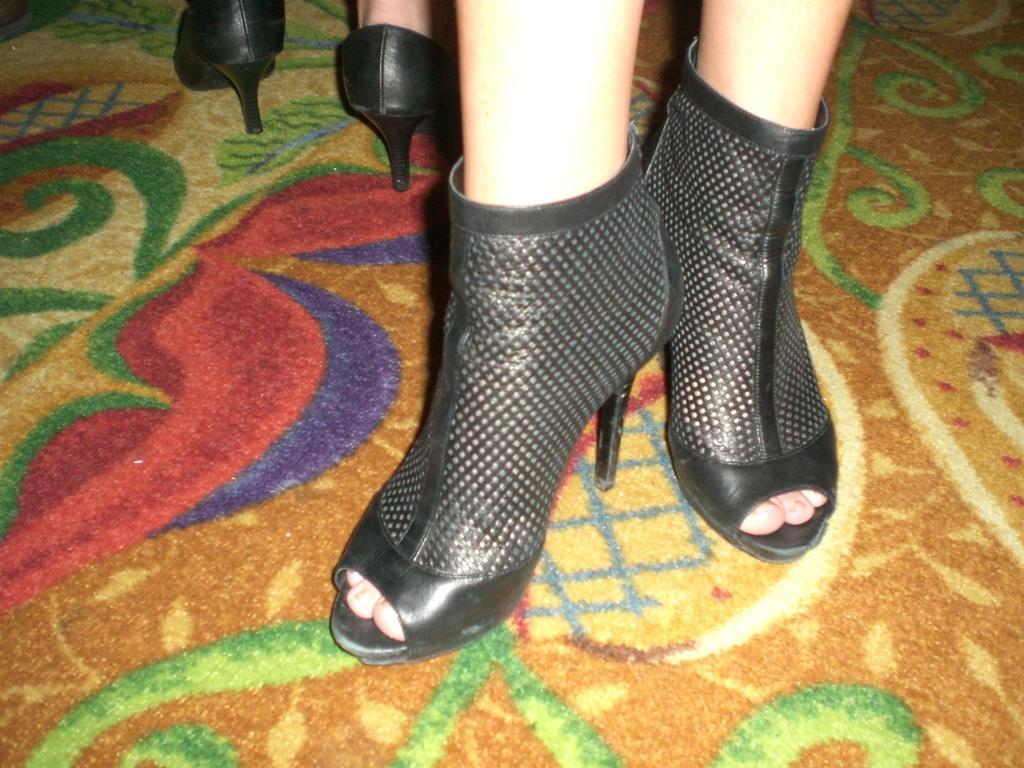What is located in the middle of the image? There are legs and footwear in the middle of the image. What is at the bottom of the image? There is a mat at the bottom of the image. What type of ring can be seen on the person's finger in the image? There is no ring visible on any person's finger in the image. What type of skin condition is present on the person's legs in the image? There is no indication of any skin condition on the person's legs in the image. 